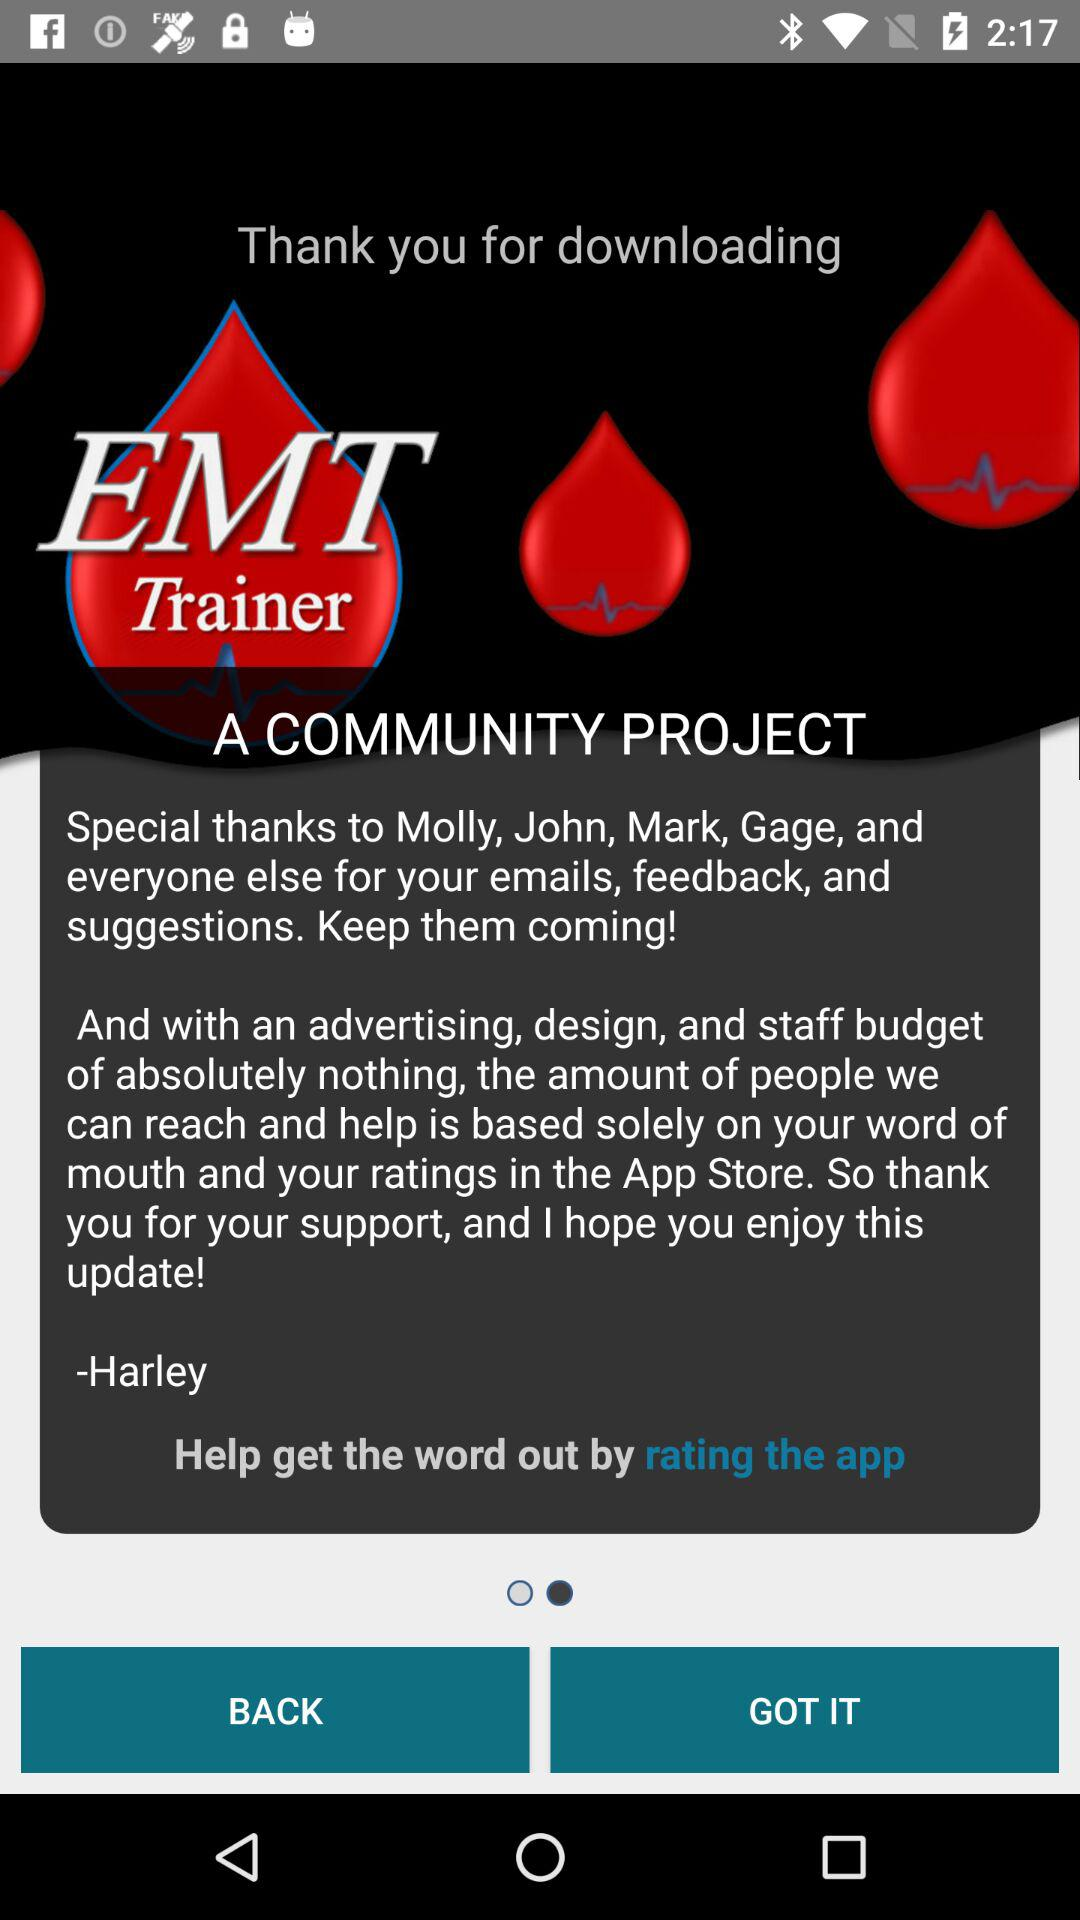Who is given special thanks in a community project? A special thanks is given to Molly, John, Mark, Gage, and everyone else. 